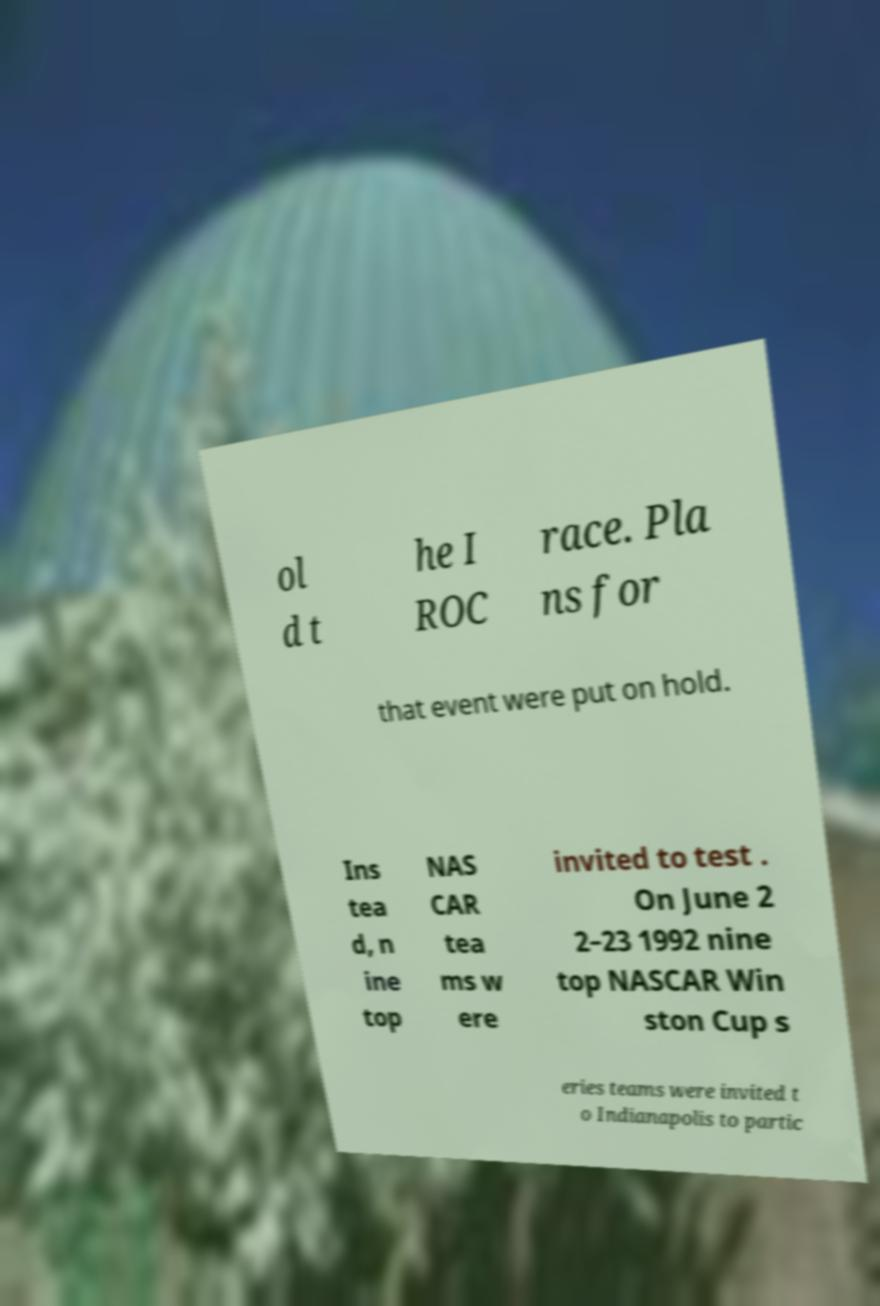Please read and relay the text visible in this image. What does it say? ol d t he I ROC race. Pla ns for that event were put on hold. Ins tea d, n ine top NAS CAR tea ms w ere invited to test . On June 2 2–23 1992 nine top NASCAR Win ston Cup s eries teams were invited t o Indianapolis to partic 